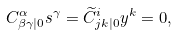Convert formula to latex. <formula><loc_0><loc_0><loc_500><loc_500>C _ { \beta \gamma | 0 } ^ { \alpha } s ^ { \gamma } = \widetilde { C } _ { j k | 0 } ^ { i } y ^ { k } = 0 ,</formula> 